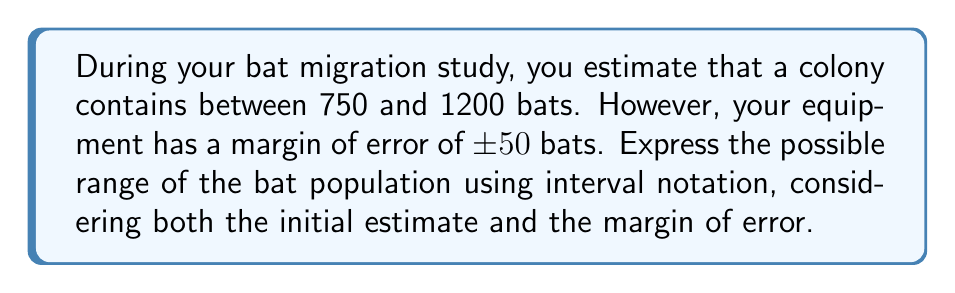Provide a solution to this math problem. Let's approach this step-by-step:

1) First, we need to consider the initial estimate:
   Lower bound: 750 bats
   Upper bound: 1200 bats

2) Now, we need to account for the margin of error of ±50 bats:
   - For the lower bound, we subtract 50: $750 - 50 = 700$
   - For the upper bound, we add 50: $1200 + 50 = 1250$

3) The true population size could be as low as 700 bats or as high as 1250 bats.

4) In interval notation, we represent this range as a closed interval because the population could be exactly 700 or 1250 bats.

5) The interval notation for this range is $[700, 1250]$, which means all real numbers x such that $700 \leq x \leq 1250$.
Answer: $[700, 1250]$ 